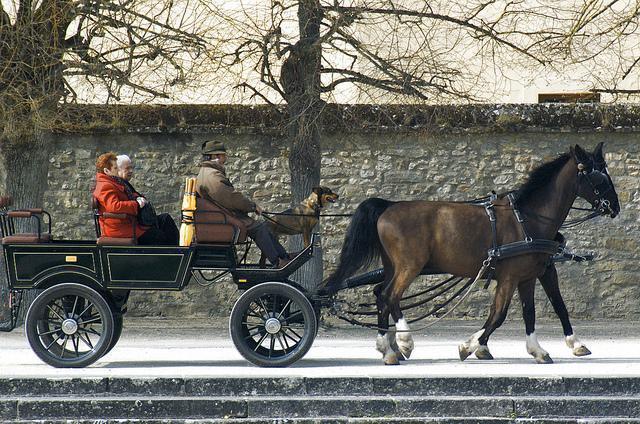In which season are the people traveling on the black horse drawn coach?
Pick the right solution, then justify: 'Answer: answer
Rationale: rationale.'
Options: Summer, spring, fall, winter. Answer: winter.
Rationale: People are in a carriage and snow is on the ground. snow is around in the winter. 